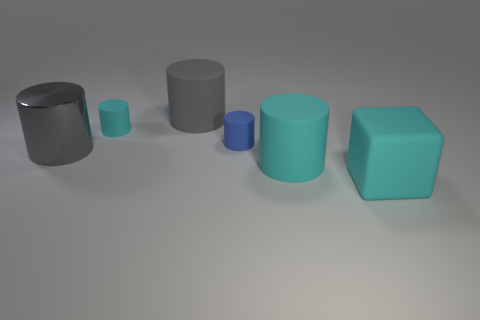What is the shape of the blue thing?
Keep it short and to the point. Cylinder. Is the number of rubber things that are behind the small blue cylinder the same as the number of big gray metal things?
Give a very brief answer. No. Does the gray object that is in front of the small cyan thing have the same material as the cyan cube?
Offer a terse response. No. Is the number of matte things that are on the left side of the metallic cylinder less than the number of gray shiny cylinders?
Ensure brevity in your answer.  Yes. How many metallic things are either tiny blue cubes or cyan cylinders?
Give a very brief answer. 0. Is there any other thing of the same color as the metal object?
Keep it short and to the point. Yes. There is a large cyan thing that is left of the matte block; does it have the same shape as the small cyan object behind the tiny blue rubber cylinder?
Offer a terse response. Yes. How many objects are either matte blocks or gray cylinders behind the shiny cylinder?
Offer a terse response. 2. How many other objects are the same size as the cyan block?
Provide a short and direct response. 3. Do the cyan object that is to the left of the small blue rubber thing and the small thing right of the tiny cyan thing have the same material?
Make the answer very short. Yes. 